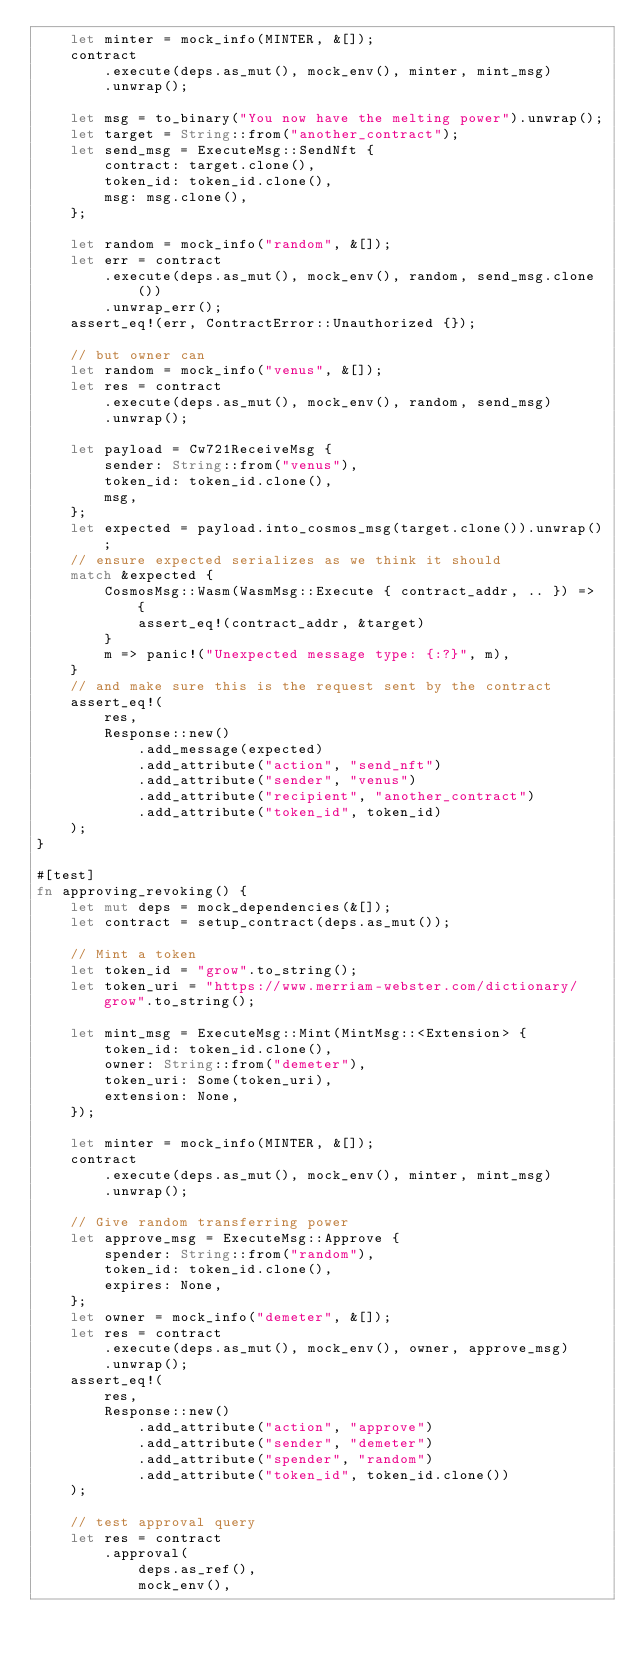Convert code to text. <code><loc_0><loc_0><loc_500><loc_500><_Rust_>    let minter = mock_info(MINTER, &[]);
    contract
        .execute(deps.as_mut(), mock_env(), minter, mint_msg)
        .unwrap();

    let msg = to_binary("You now have the melting power").unwrap();
    let target = String::from("another_contract");
    let send_msg = ExecuteMsg::SendNft {
        contract: target.clone(),
        token_id: token_id.clone(),
        msg: msg.clone(),
    };

    let random = mock_info("random", &[]);
    let err = contract
        .execute(deps.as_mut(), mock_env(), random, send_msg.clone())
        .unwrap_err();
    assert_eq!(err, ContractError::Unauthorized {});

    // but owner can
    let random = mock_info("venus", &[]);
    let res = contract
        .execute(deps.as_mut(), mock_env(), random, send_msg)
        .unwrap();

    let payload = Cw721ReceiveMsg {
        sender: String::from("venus"),
        token_id: token_id.clone(),
        msg,
    };
    let expected = payload.into_cosmos_msg(target.clone()).unwrap();
    // ensure expected serializes as we think it should
    match &expected {
        CosmosMsg::Wasm(WasmMsg::Execute { contract_addr, .. }) => {
            assert_eq!(contract_addr, &target)
        }
        m => panic!("Unexpected message type: {:?}", m),
    }
    // and make sure this is the request sent by the contract
    assert_eq!(
        res,
        Response::new()
            .add_message(expected)
            .add_attribute("action", "send_nft")
            .add_attribute("sender", "venus")
            .add_attribute("recipient", "another_contract")
            .add_attribute("token_id", token_id)
    );
}

#[test]
fn approving_revoking() {
    let mut deps = mock_dependencies(&[]);
    let contract = setup_contract(deps.as_mut());

    // Mint a token
    let token_id = "grow".to_string();
    let token_uri = "https://www.merriam-webster.com/dictionary/grow".to_string();

    let mint_msg = ExecuteMsg::Mint(MintMsg::<Extension> {
        token_id: token_id.clone(),
        owner: String::from("demeter"),
        token_uri: Some(token_uri),
        extension: None,
    });

    let minter = mock_info(MINTER, &[]);
    contract
        .execute(deps.as_mut(), mock_env(), minter, mint_msg)
        .unwrap();

    // Give random transferring power
    let approve_msg = ExecuteMsg::Approve {
        spender: String::from("random"),
        token_id: token_id.clone(),
        expires: None,
    };
    let owner = mock_info("demeter", &[]);
    let res = contract
        .execute(deps.as_mut(), mock_env(), owner, approve_msg)
        .unwrap();
    assert_eq!(
        res,
        Response::new()
            .add_attribute("action", "approve")
            .add_attribute("sender", "demeter")
            .add_attribute("spender", "random")
            .add_attribute("token_id", token_id.clone())
    );

    // test approval query
    let res = contract
        .approval(
            deps.as_ref(),
            mock_env(),</code> 